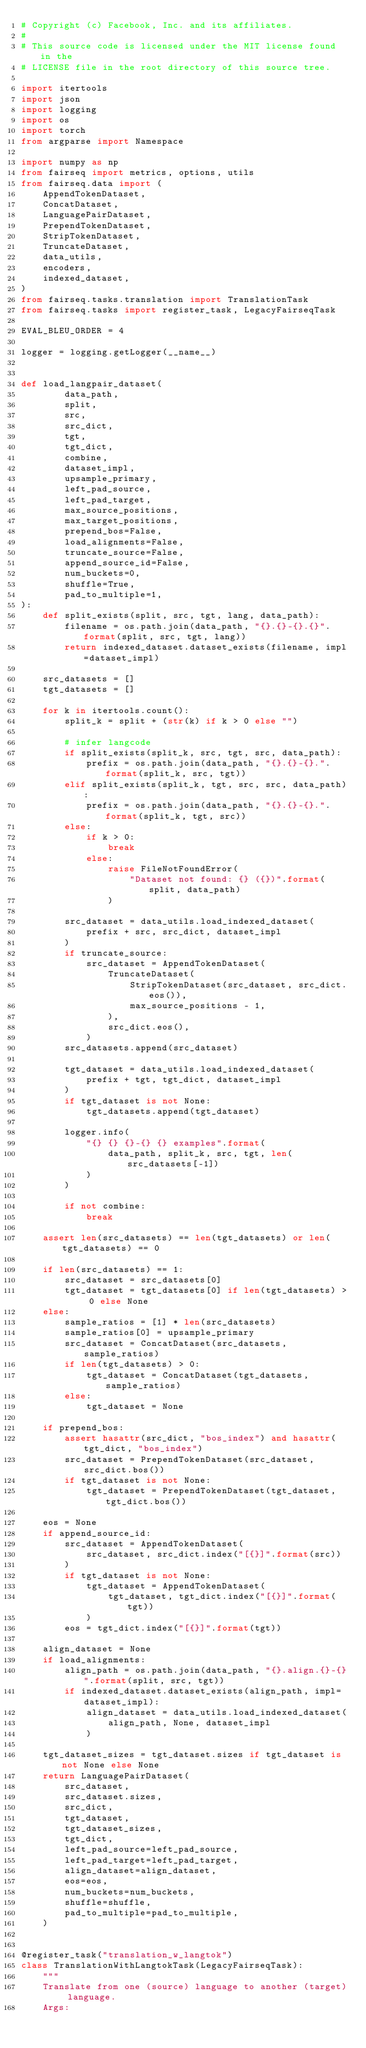Convert code to text. <code><loc_0><loc_0><loc_500><loc_500><_Python_># Copyright (c) Facebook, Inc. and its affiliates.
#
# This source code is licensed under the MIT license found in the
# LICENSE file in the root directory of this source tree.

import itertools
import json
import logging
import os
import torch
from argparse import Namespace

import numpy as np
from fairseq import metrics, options, utils
from fairseq.data import (
    AppendTokenDataset,
    ConcatDataset,
    LanguagePairDataset,
    PrependTokenDataset,
    StripTokenDataset,
    TruncateDataset,
    data_utils,
    encoders,
    indexed_dataset,
)
from fairseq.tasks.translation import TranslationTask
from fairseq.tasks import register_task, LegacyFairseqTask

EVAL_BLEU_ORDER = 4

logger = logging.getLogger(__name__)


def load_langpair_dataset(
        data_path,
        split,
        src,
        src_dict,
        tgt,
        tgt_dict,
        combine,
        dataset_impl,
        upsample_primary,
        left_pad_source,
        left_pad_target,
        max_source_positions,
        max_target_positions,
        prepend_bos=False,
        load_alignments=False,
        truncate_source=False,
        append_source_id=False,
        num_buckets=0,
        shuffle=True,
        pad_to_multiple=1,
):
    def split_exists(split, src, tgt, lang, data_path):
        filename = os.path.join(data_path, "{}.{}-{}.{}".format(split, src, tgt, lang))
        return indexed_dataset.dataset_exists(filename, impl=dataset_impl)
    
    src_datasets = []
    tgt_datasets = []
    
    for k in itertools.count():
        split_k = split + (str(k) if k > 0 else "")
        
        # infer langcode
        if split_exists(split_k, src, tgt, src, data_path):
            prefix = os.path.join(data_path, "{}.{}-{}.".format(split_k, src, tgt))
        elif split_exists(split_k, tgt, src, src, data_path):
            prefix = os.path.join(data_path, "{}.{}-{}.".format(split_k, tgt, src))
        else:
            if k > 0:
                break
            else:
                raise FileNotFoundError(
                    "Dataset not found: {} ({})".format(split, data_path)
                )
        
        src_dataset = data_utils.load_indexed_dataset(
            prefix + src, src_dict, dataset_impl
        )
        if truncate_source:
            src_dataset = AppendTokenDataset(
                TruncateDataset(
                    StripTokenDataset(src_dataset, src_dict.eos()),
                    max_source_positions - 1,
                ),
                src_dict.eos(),
            )
        src_datasets.append(src_dataset)
        
        tgt_dataset = data_utils.load_indexed_dataset(
            prefix + tgt, tgt_dict, dataset_impl
        )
        if tgt_dataset is not None:
            tgt_datasets.append(tgt_dataset)
        
        logger.info(
            "{} {} {}-{} {} examples".format(
                data_path, split_k, src, tgt, len(src_datasets[-1])
            )
        )
        
        if not combine:
            break
    
    assert len(src_datasets) == len(tgt_datasets) or len(tgt_datasets) == 0
    
    if len(src_datasets) == 1:
        src_dataset = src_datasets[0]
        tgt_dataset = tgt_datasets[0] if len(tgt_datasets) > 0 else None
    else:
        sample_ratios = [1] * len(src_datasets)
        sample_ratios[0] = upsample_primary
        src_dataset = ConcatDataset(src_datasets, sample_ratios)
        if len(tgt_datasets) > 0:
            tgt_dataset = ConcatDataset(tgt_datasets, sample_ratios)
        else:
            tgt_dataset = None
    
    if prepend_bos:
        assert hasattr(src_dict, "bos_index") and hasattr(tgt_dict, "bos_index")
        src_dataset = PrependTokenDataset(src_dataset, src_dict.bos())
        if tgt_dataset is not None:
            tgt_dataset = PrependTokenDataset(tgt_dataset, tgt_dict.bos())
    
    eos = None
    if append_source_id:
        src_dataset = AppendTokenDataset(
            src_dataset, src_dict.index("[{}]".format(src))
        )
        if tgt_dataset is not None:
            tgt_dataset = AppendTokenDataset(
                tgt_dataset, tgt_dict.index("[{}]".format(tgt))
            )
        eos = tgt_dict.index("[{}]".format(tgt))
    
    align_dataset = None
    if load_alignments:
        align_path = os.path.join(data_path, "{}.align.{}-{}".format(split, src, tgt))
        if indexed_dataset.dataset_exists(align_path, impl=dataset_impl):
            align_dataset = data_utils.load_indexed_dataset(
                align_path, None, dataset_impl
            )
    
    tgt_dataset_sizes = tgt_dataset.sizes if tgt_dataset is not None else None
    return LanguagePairDataset(
        src_dataset,
        src_dataset.sizes,
        src_dict,
        tgt_dataset,
        tgt_dataset_sizes,
        tgt_dict,
        left_pad_source=left_pad_source,
        left_pad_target=left_pad_target,
        align_dataset=align_dataset,
        eos=eos,
        num_buckets=num_buckets,
        shuffle=shuffle,
        pad_to_multiple=pad_to_multiple,
    )


@register_task("translation_w_langtok")
class TranslationWithLangtokTask(LegacyFairseqTask):
    """
    Translate from one (source) language to another (target) language.
    Args:</code> 